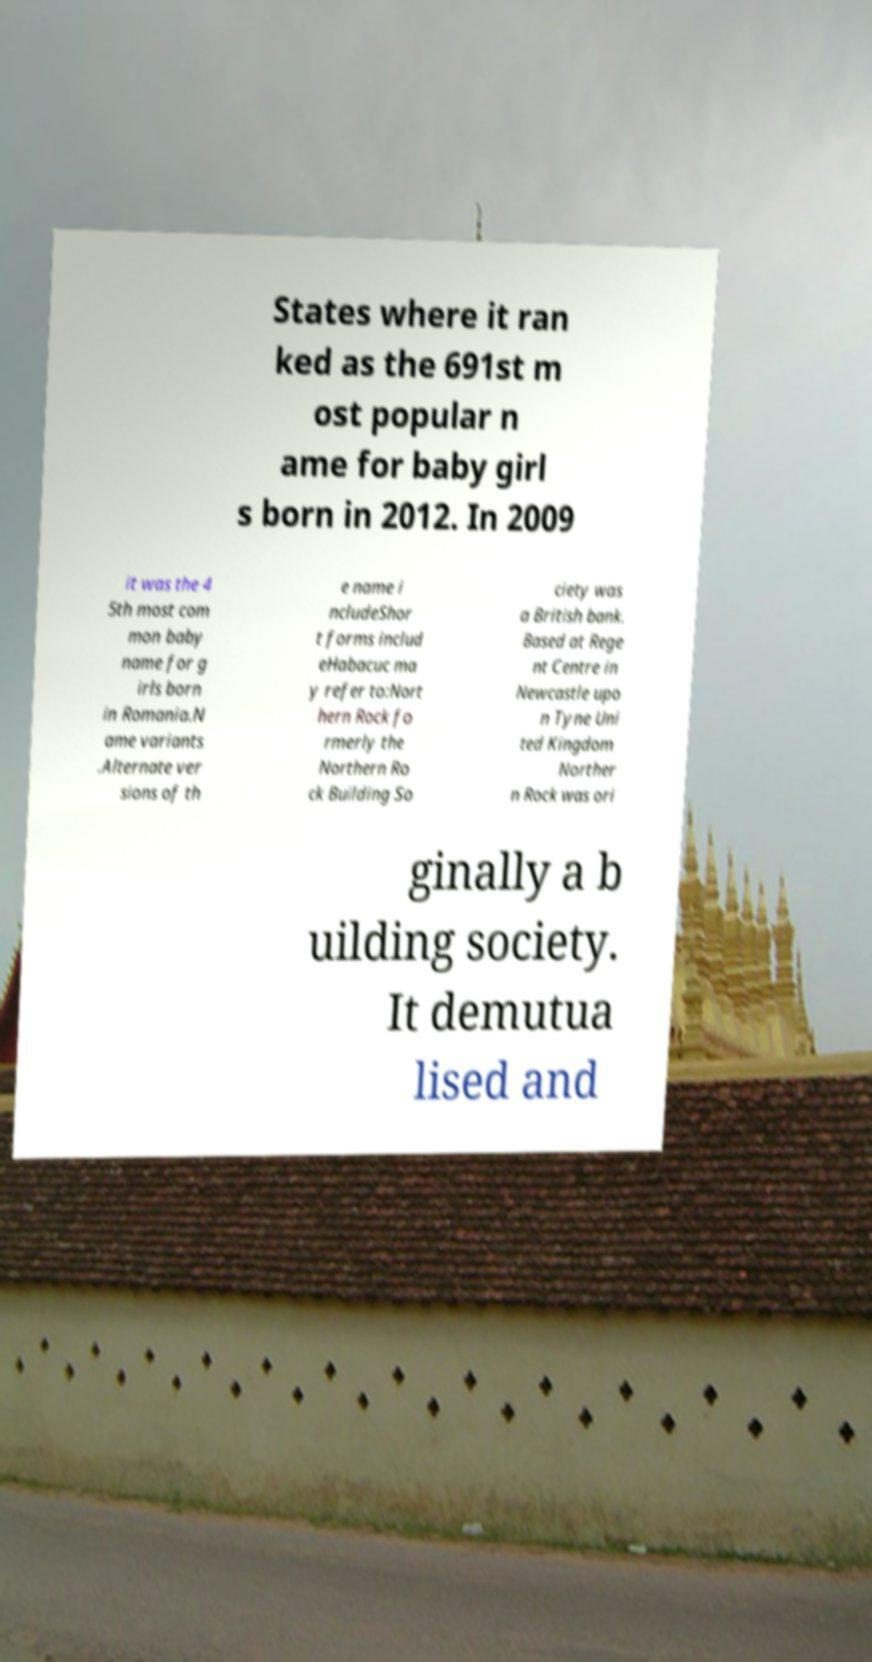I need the written content from this picture converted into text. Can you do that? States where it ran ked as the 691st m ost popular n ame for baby girl s born in 2012. In 2009 it was the 4 5th most com mon baby name for g irls born in Romania.N ame variants .Alternate ver sions of th e name i ncludeShor t forms includ eHabacuc ma y refer to:Nort hern Rock fo rmerly the Northern Ro ck Building So ciety was a British bank. Based at Rege nt Centre in Newcastle upo n Tyne Uni ted Kingdom Norther n Rock was ori ginally a b uilding society. It demutua lised and 